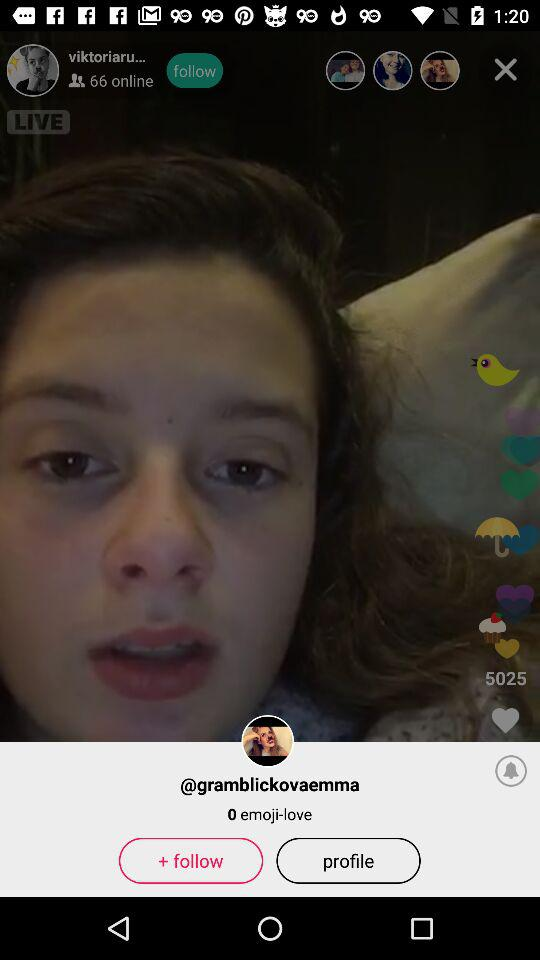How many likes are there? There are 5025 likes. 